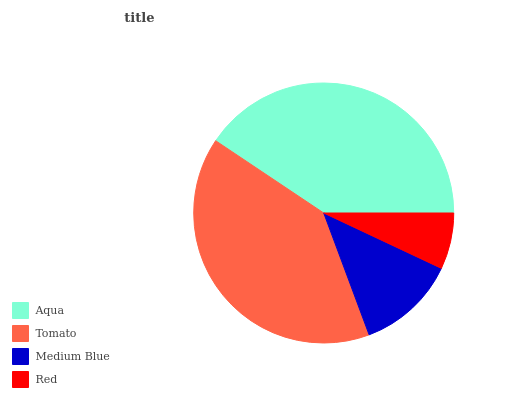Is Red the minimum?
Answer yes or no. Yes. Is Aqua the maximum?
Answer yes or no. Yes. Is Tomato the minimum?
Answer yes or no. No. Is Tomato the maximum?
Answer yes or no. No. Is Aqua greater than Tomato?
Answer yes or no. Yes. Is Tomato less than Aqua?
Answer yes or no. Yes. Is Tomato greater than Aqua?
Answer yes or no. No. Is Aqua less than Tomato?
Answer yes or no. No. Is Tomato the high median?
Answer yes or no. Yes. Is Medium Blue the low median?
Answer yes or no. Yes. Is Aqua the high median?
Answer yes or no. No. Is Red the low median?
Answer yes or no. No. 